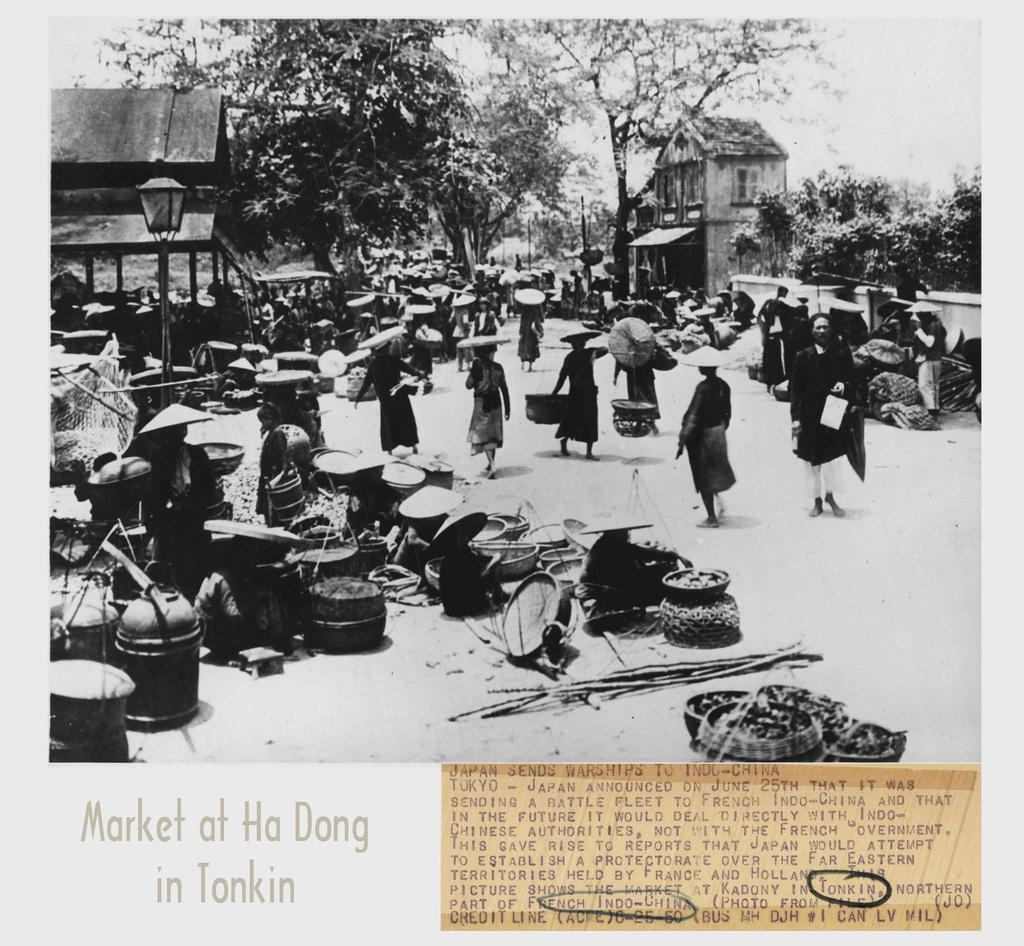<image>
Present a compact description of the photo's key features. Old photo of Market at Ha Dong in Tonkin showing people shopping. 